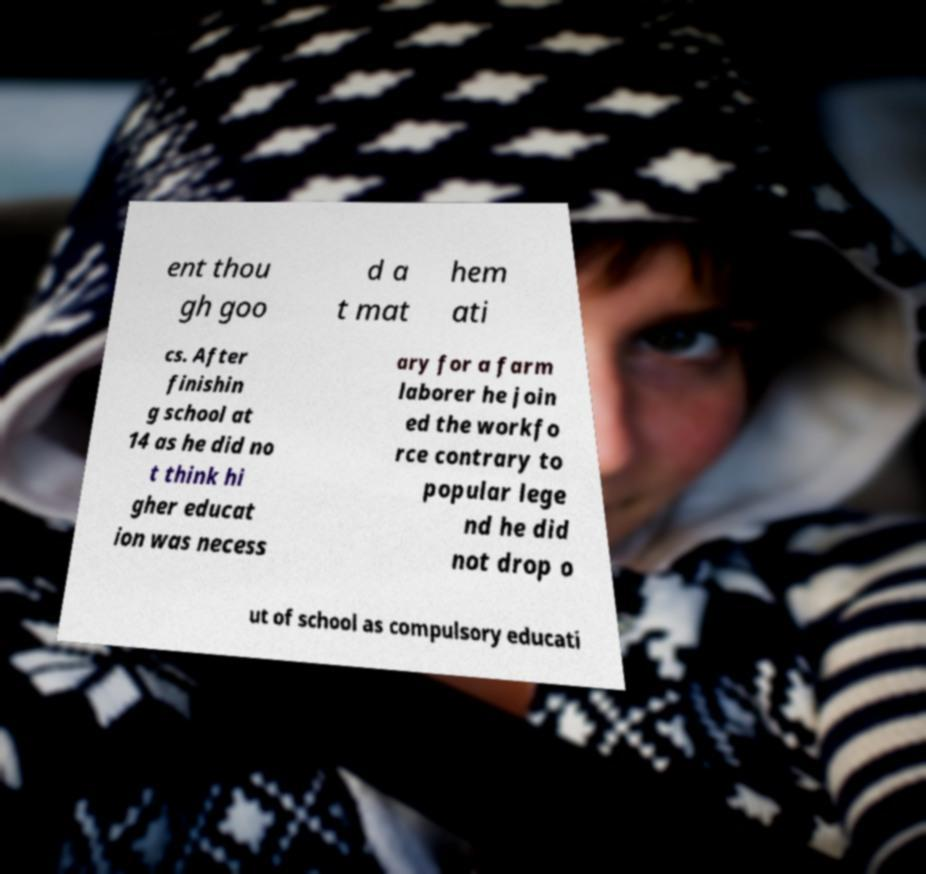There's text embedded in this image that I need extracted. Can you transcribe it verbatim? ent thou gh goo d a t mat hem ati cs. After finishin g school at 14 as he did no t think hi gher educat ion was necess ary for a farm laborer he join ed the workfo rce contrary to popular lege nd he did not drop o ut of school as compulsory educati 